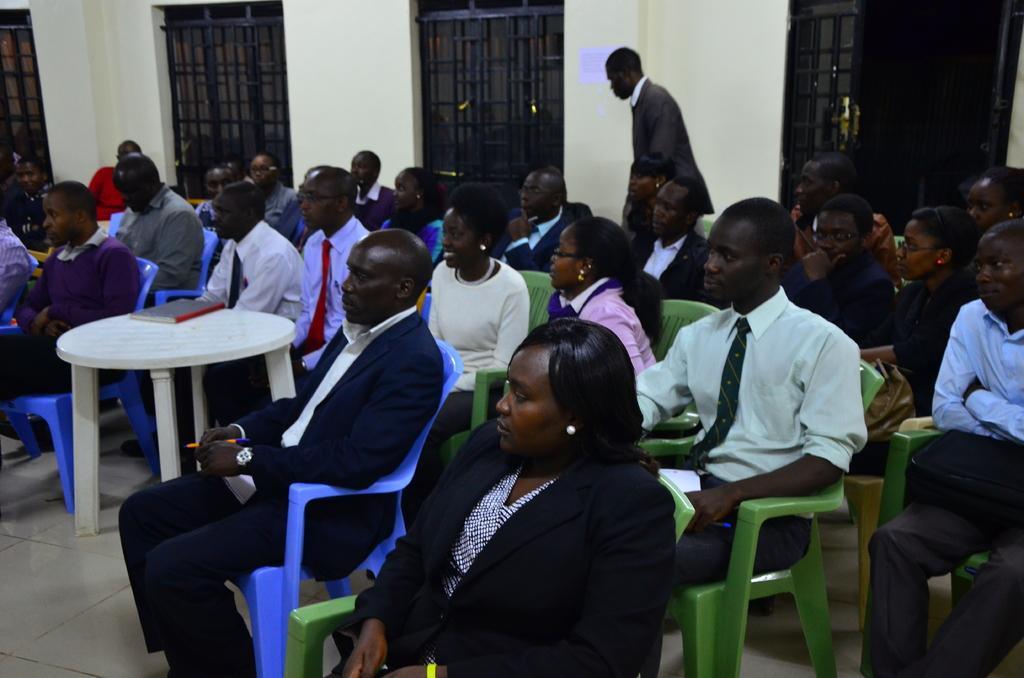Please provide a concise description of this image. In this image there are grilles, walls, people, table, book, tile floor and objects. Among them one person is standing. Poster is on the wall. On the table there is a book. 